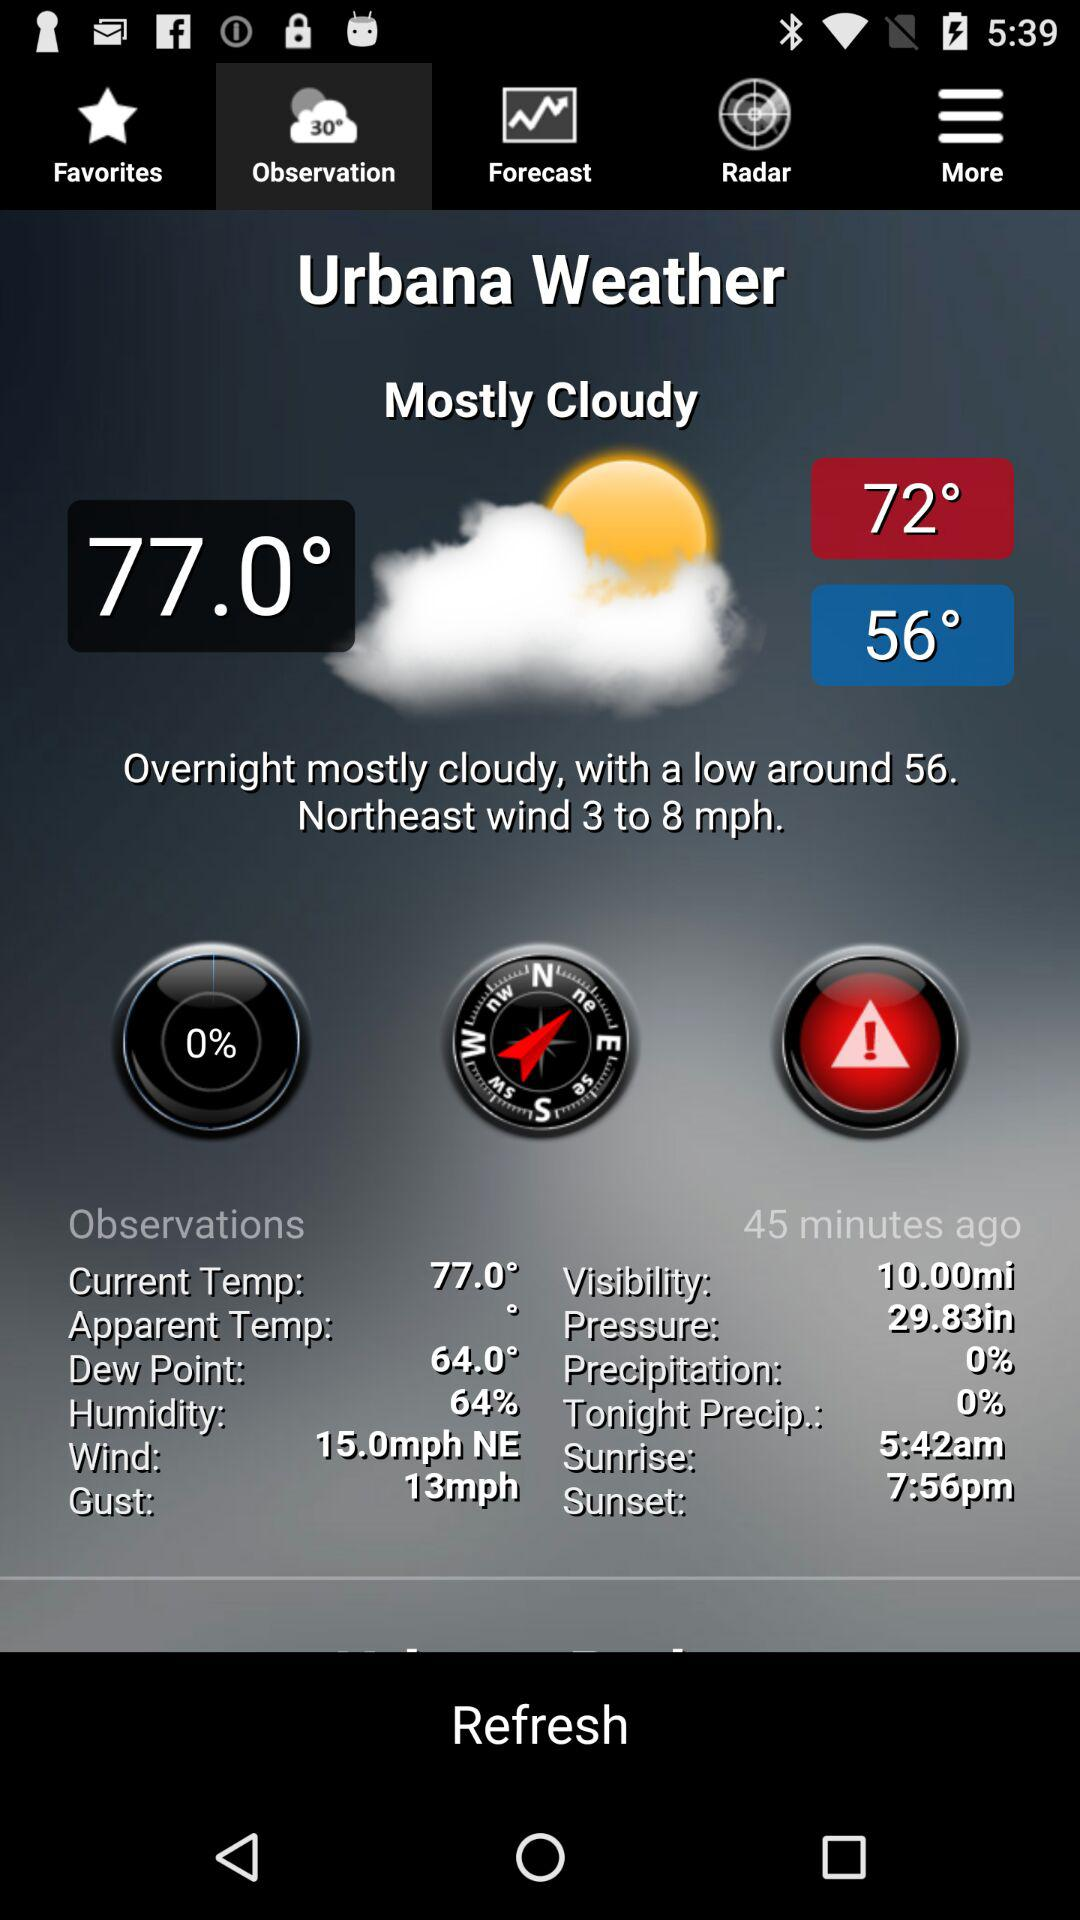What is the wind speed for the current observation?
Answer the question using a single word or phrase. 3 to 8 mph 